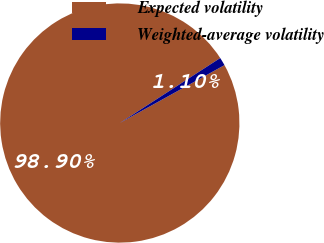Convert chart. <chart><loc_0><loc_0><loc_500><loc_500><pie_chart><fcel>Expected volatility<fcel>Weighted-average volatility<nl><fcel>98.9%<fcel>1.1%<nl></chart> 